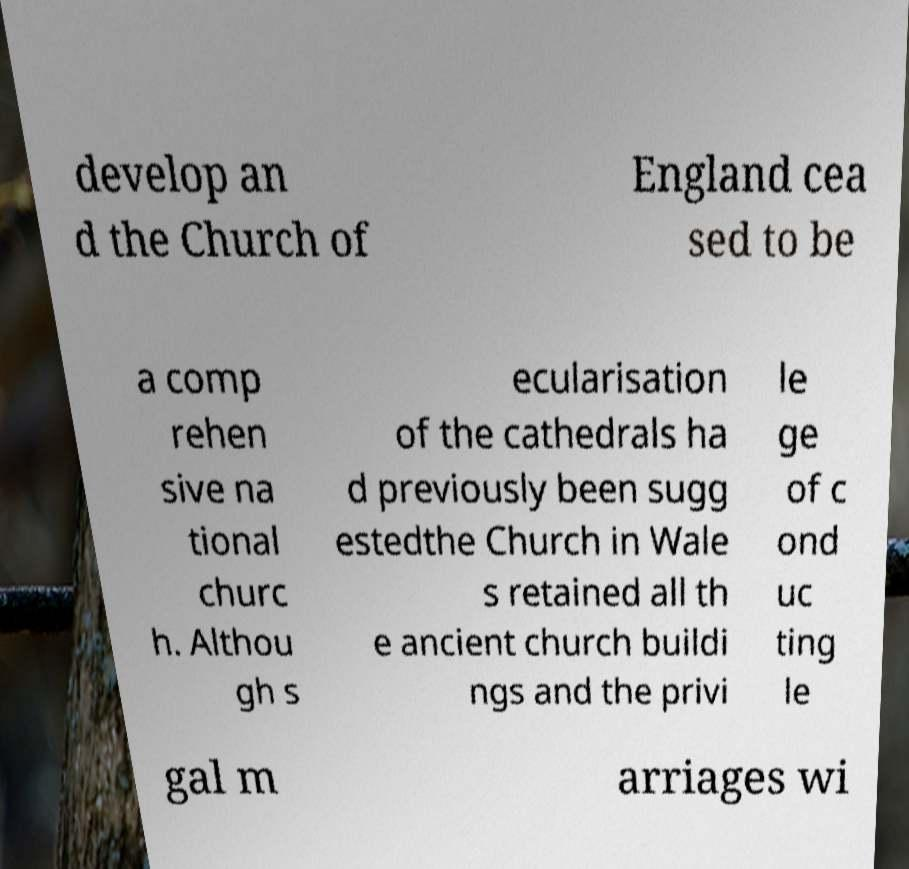Could you extract and type out the text from this image? develop an d the Church of England cea sed to be a comp rehen sive na tional churc h. Althou gh s ecularisation of the cathedrals ha d previously been sugg estedthe Church in Wale s retained all th e ancient church buildi ngs and the privi le ge of c ond uc ting le gal m arriages wi 